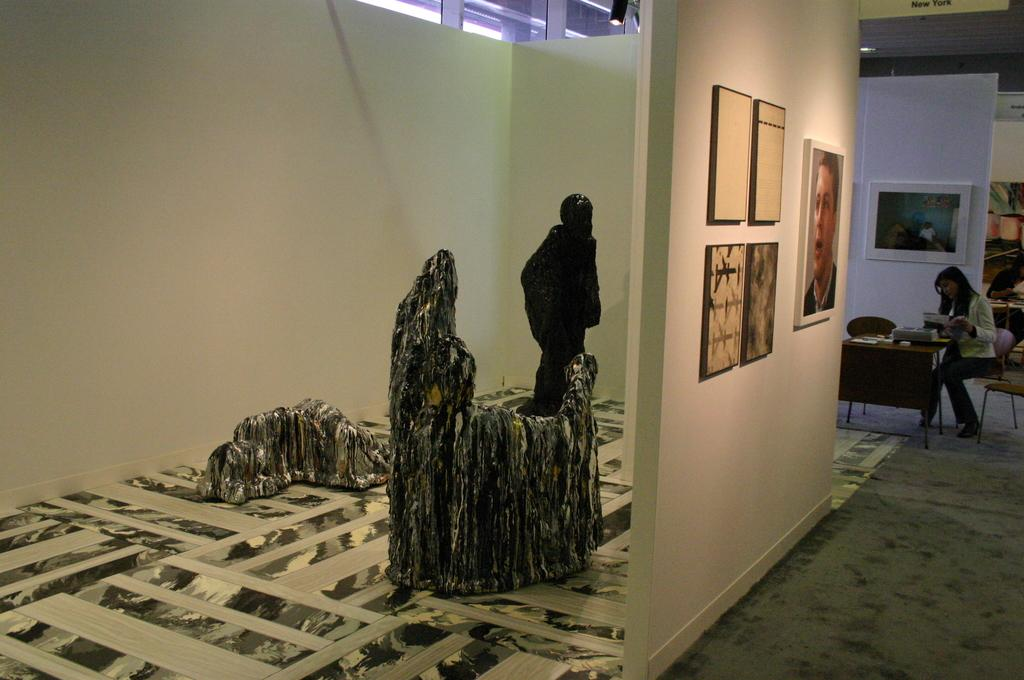What type of natural elements can be seen in the image? There are rocks in the image. What are the two persons in the image doing? They are sitting on chairs. What can be found on the tables in the image? There are objects on tables. What is attached to the wall in the image? There are frames attached to the wall. Can you tell me how many clams are sitting on the rocks in the image? There are no clams present in the image; it features rocks, chairs, tables, and frames. What type of lizards can be seen crawling on the frames in the image? There are no lizards present in the image; it only features rocks, chairs, tables, and frames. 